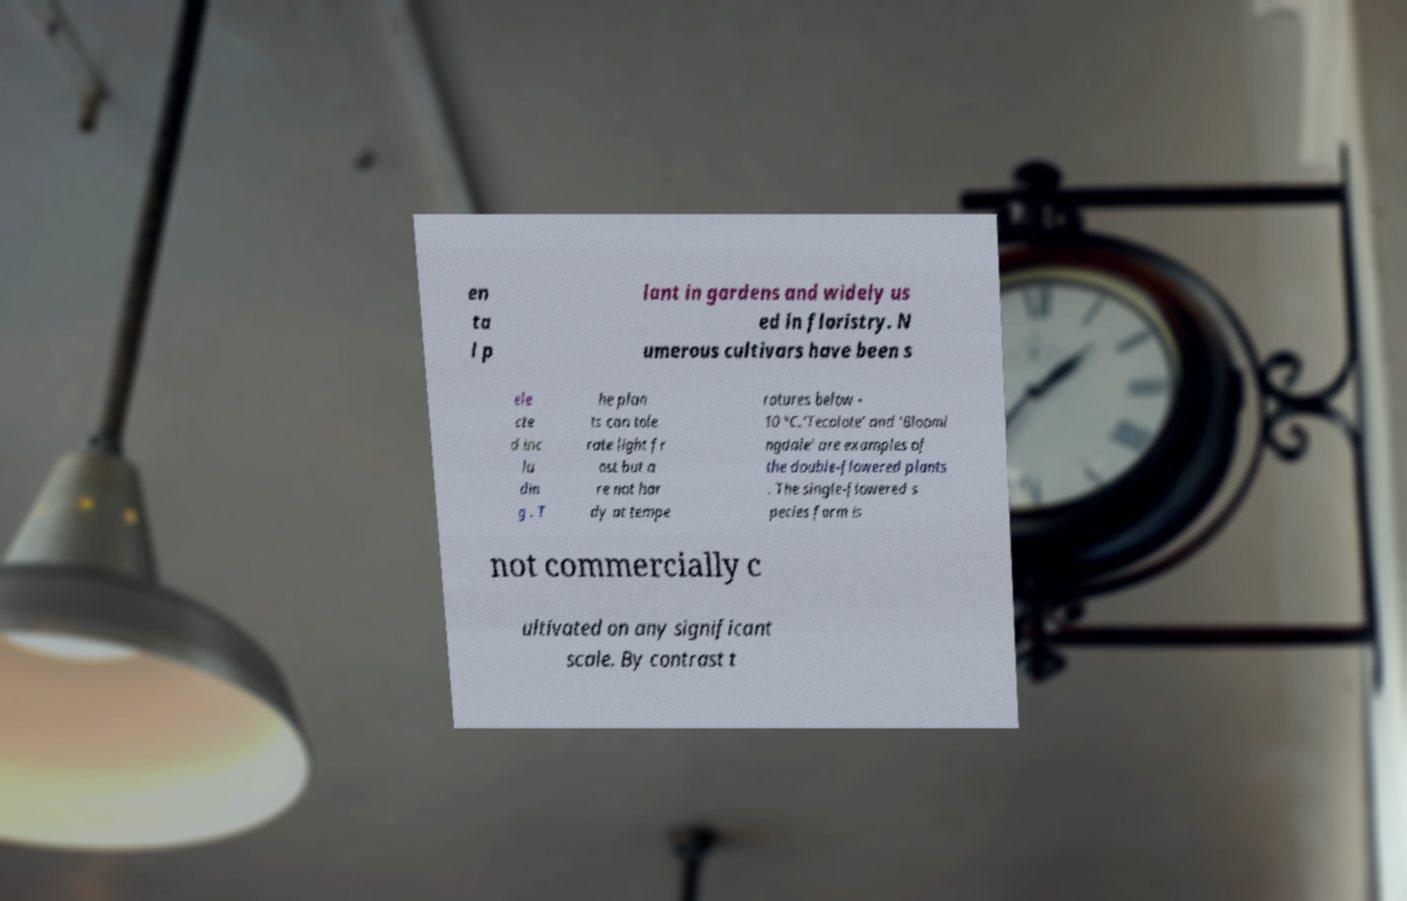Please read and relay the text visible in this image. What does it say? en ta l p lant in gardens and widely us ed in floristry. N umerous cultivars have been s ele cte d inc lu din g . T he plan ts can tole rate light fr ost but a re not har dy at tempe ratures below - 10 °C.'Tecolote' and 'Bloomi ngdale' are examples of the double-flowered plants . The single-flowered s pecies form is not commercially c ultivated on any significant scale. By contrast t 